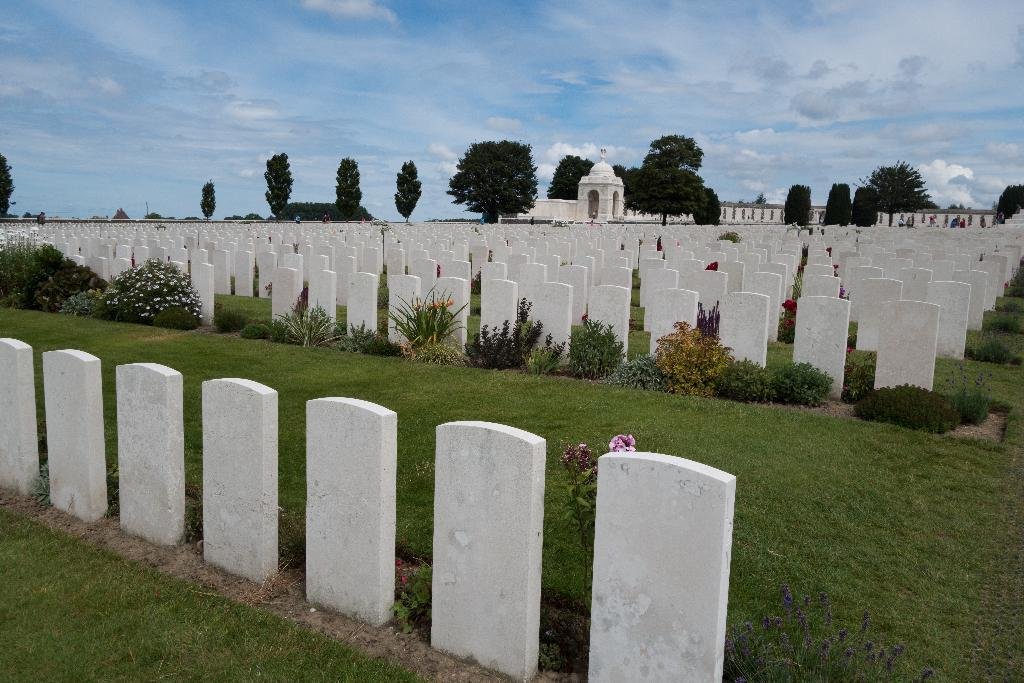What is placed on the floor in the image? There are cemeteries on the floor in the image. What type of vegetation can be seen in the image? There are plants and trees in the image. What type of structure is visible in the image? There is a building visible in the image. What type of writing can be seen on the cemeteries in the image? There is no writing visible on the cemeteries in the image. Is there a party happening in the image? There is no indication of a party in the image. 